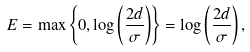Convert formula to latex. <formula><loc_0><loc_0><loc_500><loc_500>E = \max \left \{ 0 , \log \left ( \frac { 2 d } { \sigma } \right ) \right \} = \log \left ( \frac { 2 d } { \sigma } \right ) ,</formula> 